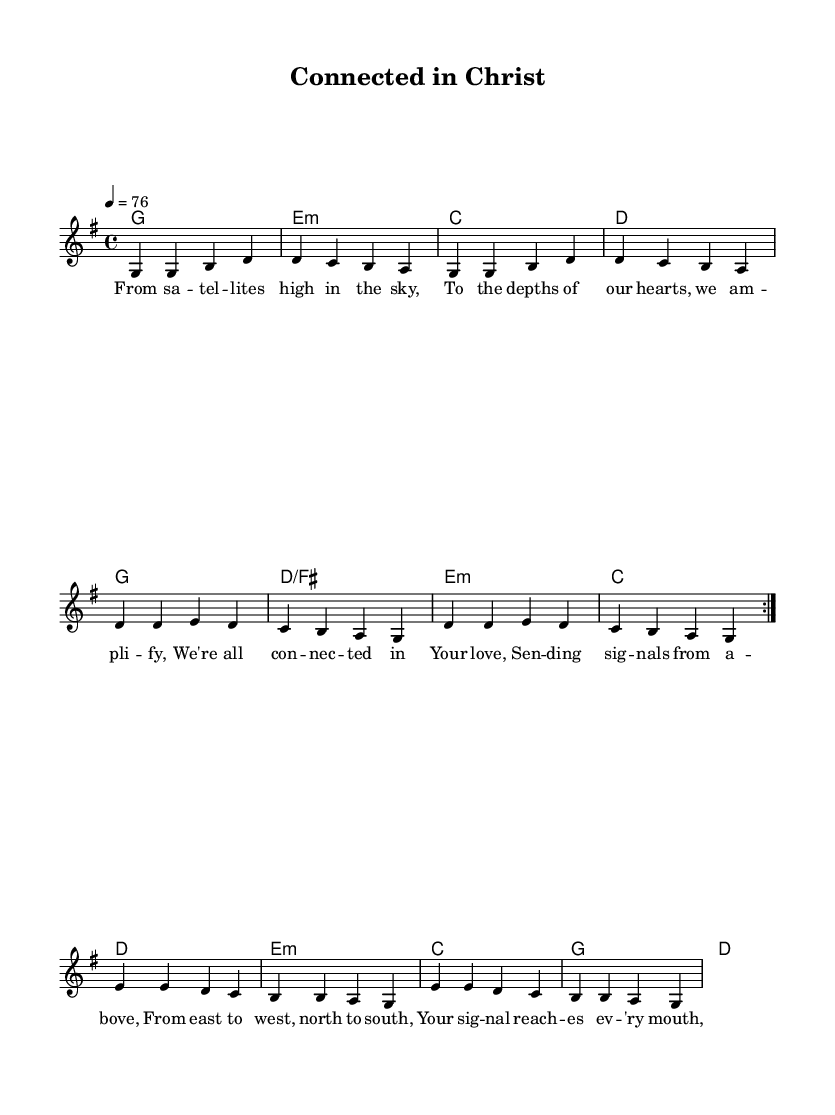What is the key signature of this music? The key signature is G major, which has one sharp (F#). This can be determined from the initial indication in the `global` section of the code, where it states \key g \major.
Answer: G major What is the time signature of the piece? The time signature is 4/4, as stated in the `global` section of the code where \time 4/4 is specified. This indicates that there are four beats in each measure.
Answer: 4/4 What is the tempo marking for this composition? The tempo marking is quarter note equals seventy-six, indicated by \tempo 4 = 76 in the `global` section. This means the piece should be played at a speed of seventy-six quarter notes per minute.
Answer: seventy-six How many verses does the song have? The song includes one verse section with repeated phrases indicated by the \repeat volta 2, where lyrics for the verse are provided. This implies that the verse is meant to be sung twice.
Answer: 1 What is the message conveyed through the bridge lyrics? The bridge lyrics convey a message of global unity, as they address the reaching of signals from God from the east to west and north to south, suggesting the omnipresence of His message. This can be inferred from the lyrics: "From east to west, north to south, Your signal reaches every mouth."
Answer: global unity What type of chords are used in the verse? The chords used in the verse are G, E minor, C, and D, which are common chords in modern worship music and highlight a simple harmonic structure that supports the lyrical themes. These can be seen in the verse_chords section of the code.
Answer: G, E minor, C, D 